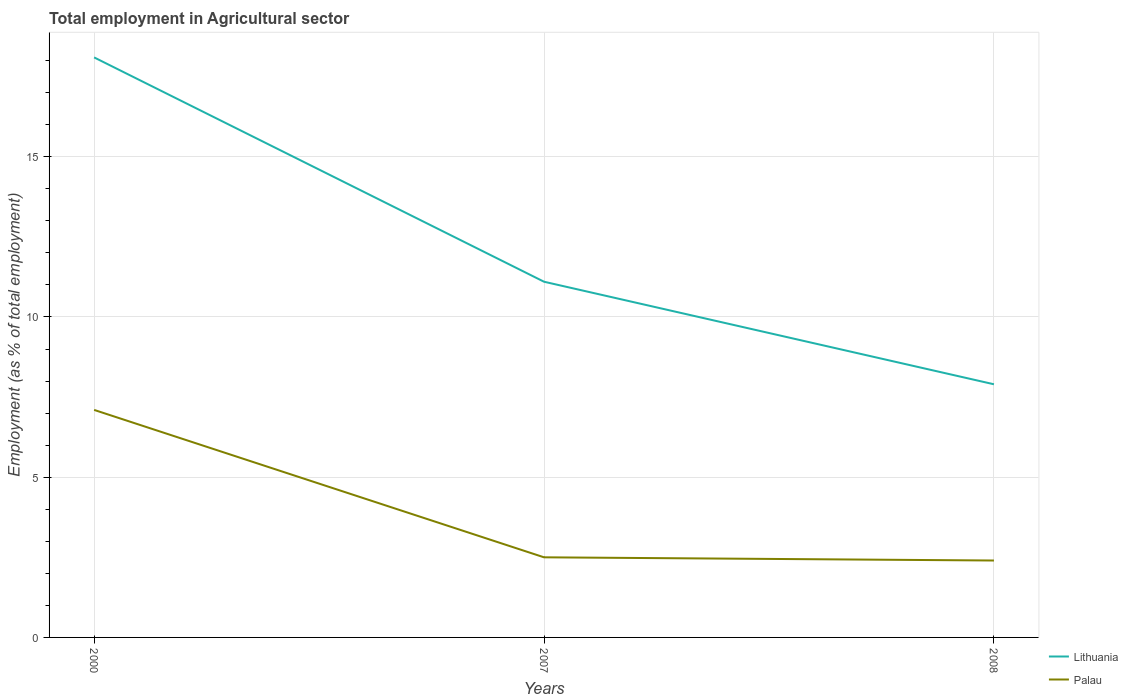How many different coloured lines are there?
Offer a terse response. 2. Across all years, what is the maximum employment in agricultural sector in Palau?
Give a very brief answer. 2.4. In which year was the employment in agricultural sector in Palau maximum?
Keep it short and to the point. 2008. What is the total employment in agricultural sector in Palau in the graph?
Provide a short and direct response. 0.1. What is the difference between the highest and the second highest employment in agricultural sector in Palau?
Your response must be concise. 4.7. What is the difference between the highest and the lowest employment in agricultural sector in Palau?
Your response must be concise. 1. Is the employment in agricultural sector in Lithuania strictly greater than the employment in agricultural sector in Palau over the years?
Your answer should be very brief. No. Does the graph contain grids?
Your answer should be compact. Yes. Where does the legend appear in the graph?
Your answer should be very brief. Bottom right. How many legend labels are there?
Make the answer very short. 2. How are the legend labels stacked?
Your answer should be very brief. Vertical. What is the title of the graph?
Offer a very short reply. Total employment in Agricultural sector. Does "Oman" appear as one of the legend labels in the graph?
Ensure brevity in your answer.  No. What is the label or title of the Y-axis?
Ensure brevity in your answer.  Employment (as % of total employment). What is the Employment (as % of total employment) in Lithuania in 2000?
Offer a terse response. 18.1. What is the Employment (as % of total employment) in Palau in 2000?
Provide a succinct answer. 7.1. What is the Employment (as % of total employment) of Lithuania in 2007?
Ensure brevity in your answer.  11.1. What is the Employment (as % of total employment) of Palau in 2007?
Provide a succinct answer. 2.5. What is the Employment (as % of total employment) in Lithuania in 2008?
Make the answer very short. 7.9. What is the Employment (as % of total employment) of Palau in 2008?
Your answer should be compact. 2.4. Across all years, what is the maximum Employment (as % of total employment) in Lithuania?
Keep it short and to the point. 18.1. Across all years, what is the maximum Employment (as % of total employment) in Palau?
Give a very brief answer. 7.1. Across all years, what is the minimum Employment (as % of total employment) of Lithuania?
Your answer should be compact. 7.9. Across all years, what is the minimum Employment (as % of total employment) in Palau?
Give a very brief answer. 2.4. What is the total Employment (as % of total employment) in Lithuania in the graph?
Offer a terse response. 37.1. What is the total Employment (as % of total employment) of Palau in the graph?
Keep it short and to the point. 12. What is the difference between the Employment (as % of total employment) in Lithuania in 2000 and that in 2007?
Make the answer very short. 7. What is the difference between the Employment (as % of total employment) of Palau in 2000 and that in 2007?
Your answer should be very brief. 4.6. What is the difference between the Employment (as % of total employment) in Palau in 2000 and that in 2008?
Provide a succinct answer. 4.7. What is the difference between the Employment (as % of total employment) of Lithuania in 2007 and that in 2008?
Provide a short and direct response. 3.2. What is the difference between the Employment (as % of total employment) in Palau in 2007 and that in 2008?
Offer a very short reply. 0.1. What is the difference between the Employment (as % of total employment) in Lithuania in 2000 and the Employment (as % of total employment) in Palau in 2007?
Provide a short and direct response. 15.6. What is the average Employment (as % of total employment) of Lithuania per year?
Keep it short and to the point. 12.37. In the year 2000, what is the difference between the Employment (as % of total employment) of Lithuania and Employment (as % of total employment) of Palau?
Provide a short and direct response. 11. What is the ratio of the Employment (as % of total employment) of Lithuania in 2000 to that in 2007?
Your response must be concise. 1.63. What is the ratio of the Employment (as % of total employment) in Palau in 2000 to that in 2007?
Make the answer very short. 2.84. What is the ratio of the Employment (as % of total employment) of Lithuania in 2000 to that in 2008?
Offer a terse response. 2.29. What is the ratio of the Employment (as % of total employment) in Palau in 2000 to that in 2008?
Ensure brevity in your answer.  2.96. What is the ratio of the Employment (as % of total employment) in Lithuania in 2007 to that in 2008?
Give a very brief answer. 1.41. What is the ratio of the Employment (as % of total employment) in Palau in 2007 to that in 2008?
Provide a short and direct response. 1.04. What is the difference between the highest and the second highest Employment (as % of total employment) in Lithuania?
Offer a very short reply. 7. What is the difference between the highest and the lowest Employment (as % of total employment) of Lithuania?
Ensure brevity in your answer.  10.2. 